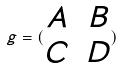<formula> <loc_0><loc_0><loc_500><loc_500>g = ( \begin{matrix} A & B \\ C & D \end{matrix} )</formula> 